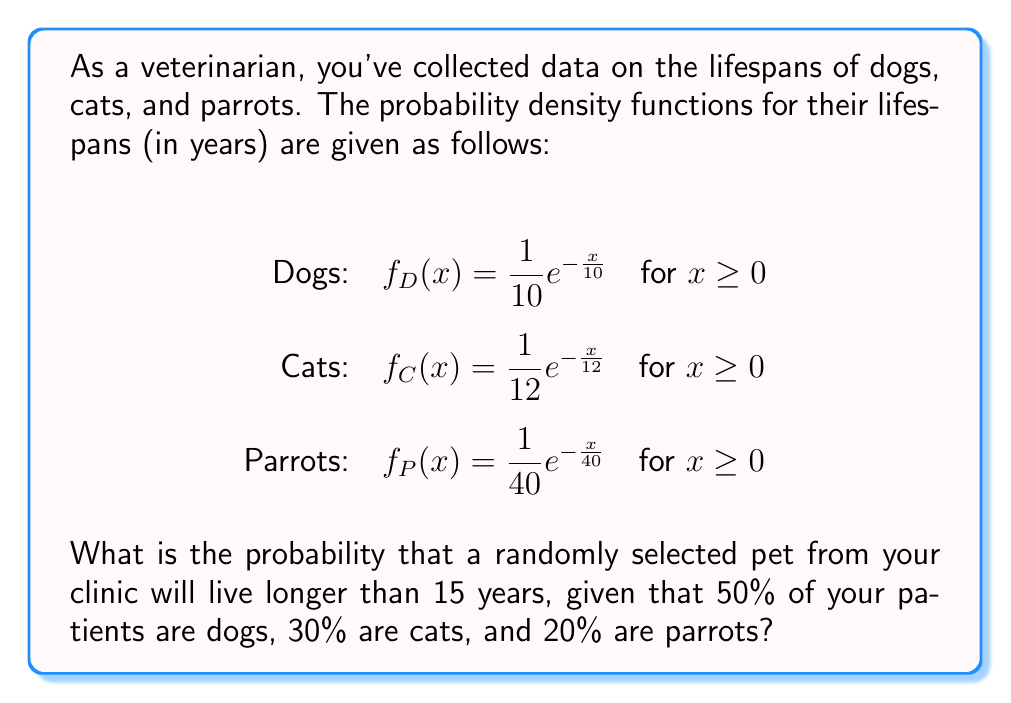Provide a solution to this math problem. To solve this problem, we'll follow these steps:

1) First, we need to calculate the probability of each type of pet living longer than 15 years.

2) For an exponential distribution with parameter $\lambda$, the probability of living longer than $t$ years is given by $P(X > t) = e^{-\frac{t}{\lambda}}$.

3) For dogs: $P(X_D > 15) = e^{-\frac{15}{10}} = e^{-1.5} \approx 0.2231$

4) For cats: $P(X_C > 15) = e^{-\frac{15}{12}} = e^{-1.25} \approx 0.2865$

5) For parrots: $P(X_P > 15) = e^{-\frac{15}{40}} = e^{-0.375} \approx 0.6873$

6) Now, we use the law of total probability. Let A be the event that a pet lives longer than 15 years.

   $P(A) = P(A|D)P(D) + P(A|C)P(C) + P(A|P)P(P)$

   Where D, C, and P represent the events of selecting a dog, cat, or parrot respectively.

7) Substituting the values:

   $P(A) = 0.2231 * 0.50 + 0.2865 * 0.30 + 0.6873 * 0.20$

8) Calculating:

   $P(A) = 0.11155 + 0.08595 + 0.13746 = 0.33496$

Therefore, the probability is approximately 0.3350 or 33.50%.
Answer: 0.3350 